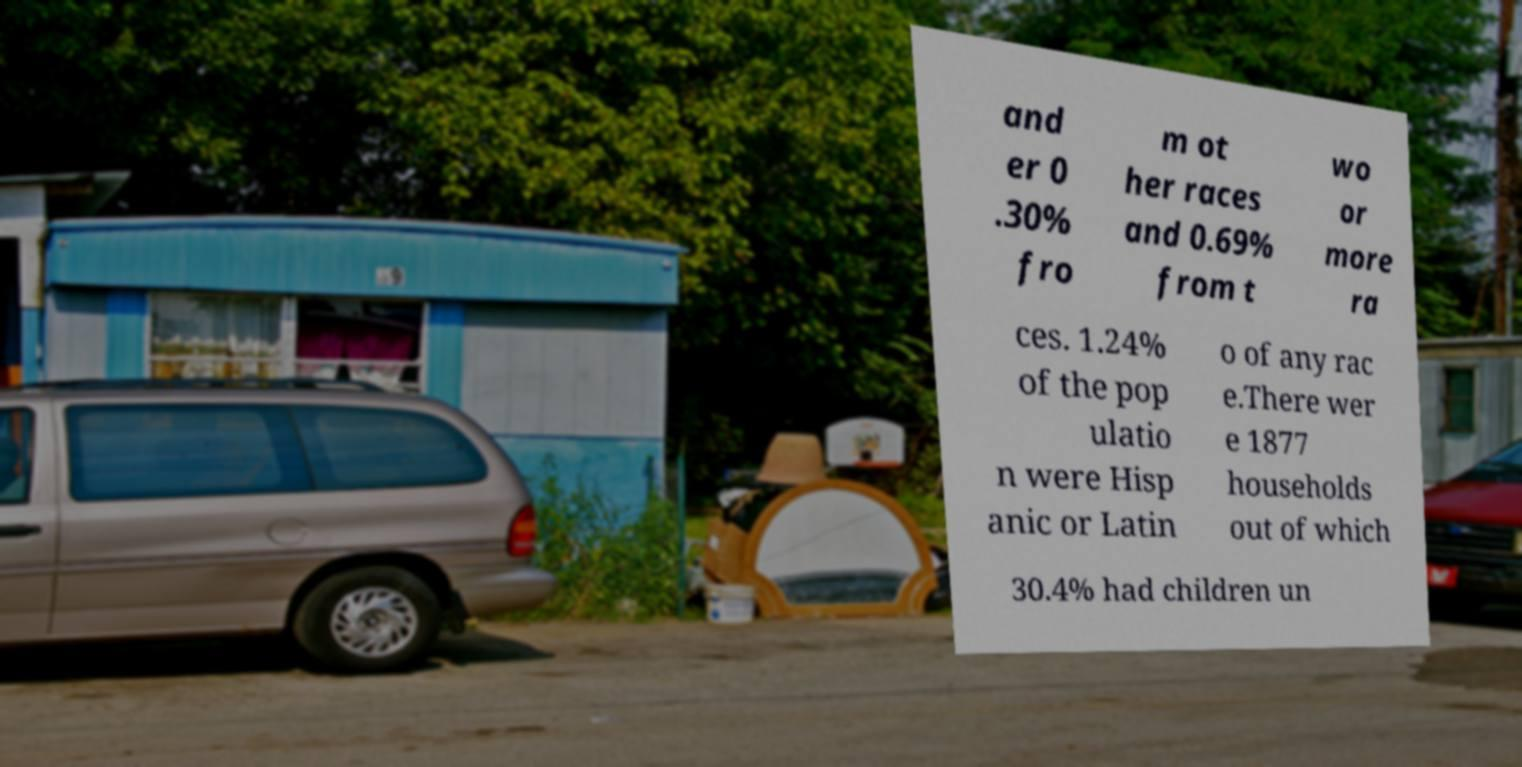Please read and relay the text visible in this image. What does it say? and er 0 .30% fro m ot her races and 0.69% from t wo or more ra ces. 1.24% of the pop ulatio n were Hisp anic or Latin o of any rac e.There wer e 1877 households out of which 30.4% had children un 